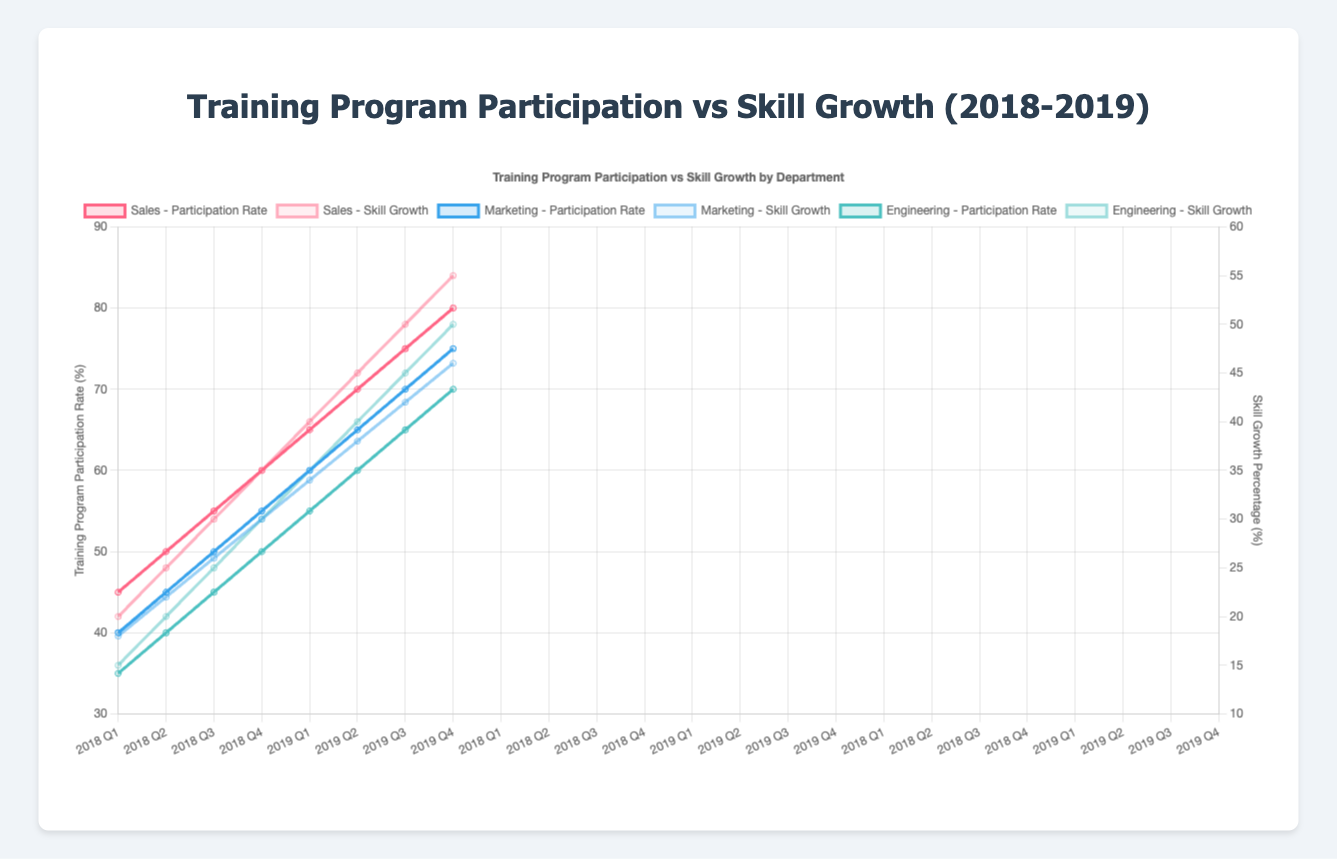What is the overall trend in Training Program Participation Rates for the Sales department from 2018 to 2019? The trend in Training Program Participation Rates for the Sales department shows a steady increase from 45% in Q1 2018 to 80% in Q4 2019. This can be observed by looking at the Sales Department's Participation Rate line, which consistently rises over time.
Answer: Steady increase Compare the Skill Growth Percentage between the Sales and Marketing department in Q3 2019. Which department had a higher growth? In Q3 2019, the Skill Growth Percentage for the Sales department is 50%, and for the Marketing department, it is 42%. By comparing these two values, we see that the Sales department had a higher skill growth.
Answer: Sales Calculate the average Training Program Participation Rate for the Engineering department in 2018. To find the average, sum the participation rates for the four quarters in 2018 (35% + 40% + 45% + 50%) = 170%, and then divide by 4 quarters. Thus, the average participation rate is 170/4 = 42.5%.
Answer: 42.5% What color represents the Skill Growth for the Marketing department on the chart? The Skill Growth for the Marketing department is represented by a blue line that is lighter (partial transparency) compared to the Training Program Participation Rate for the same department, which is a solid blue line.
Answer: Blue By how much did the Training Program Participation Rate in the Engineering department increase from Q1 2018 to Q4 2019? The Training Program Participation Rate in the Engineering department was 35% in Q1 2018 and increased to 70% in Q4 2019. The increase is calculated by subtracting the initial value from the final value (70% - 35%) = 35%.
Answer: 35% Which quarter in 2019 saw the highest Skill Growth Percentage in the Sales department, and what was the percentage? Observing the Sales department's Skill Growth Percentage line for 2019, Q4 shows the highest Skill Growth Percentage at 55%.
Answer: Q4, 55% Visualize and describe the overlapping trend of Skill Growth Percentage and Training Program Participation Rate for the Marketing department throughout 2019. Throughout 2019, both the Skill Growth Percentage and Training Program Participation Rate for the Marketing department show a rising trend. The Training Program Participation Rate line (solid blue) starts at 60% and ends at 75%, while the Skill Growth line (light blue) starts at 34% and ends at 46%. Visually, both lines follow a similar upward trajectory.
Answer: Rising trend Compare the rate of increase in Skill Growth from Q1 to Q2 of 2019 for the Sales and Engineering departments. Which department had a higher rate of increase? For the Sales department, the Skill Growth increased from 40% in Q1 to 45% in Q2, an increase of 5%. For Engineering, it increased from 35% to 40%, also 5%. Both departments had the same rate of increase.
Answer: Same rate (5%) 